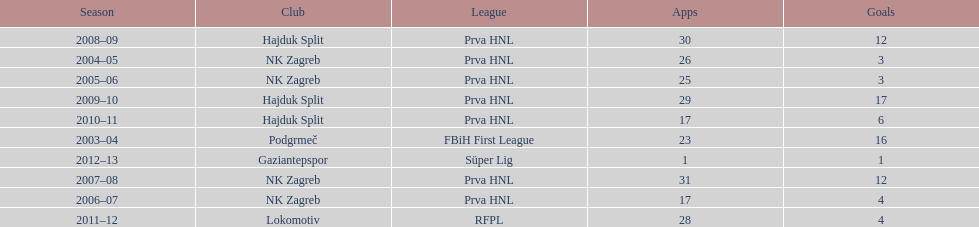What were the names of each club where more than 15 goals were scored in a single season? Podgrmeč, Hajduk Split. 